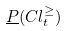<formula> <loc_0><loc_0><loc_500><loc_500>\underline { P } ( C l _ { t } ^ { \geq } )</formula> 